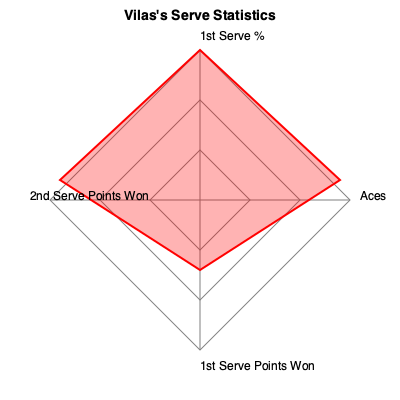Based on the radar chart showing Guillermo Vilas's serve statistics, which aspect of his serve appears to be his strongest? To determine Guillermo Vilas's strongest serving aspect, we need to analyze the radar chart:

1. The chart shows four serve statistics: Aces, 1st Serve %, 2nd Serve Points Won, and 1st Serve Points Won.

2. The red area represents Vilas's performance in each category.

3. The larger the area extends towards a vertex, the better the performance in that category.

4. Comparing the four categories:
   - Aces: Extends about halfway to the outer polygon
   - 1st Serve %: Extends close to the outer polygon
   - 2nd Serve Points Won: Extends slightly less than halfway to the outer polygon
   - 1st Serve Points Won: Extends about two-thirds to the outer polygon

5. The 1st Serve % clearly extends the furthest towards its vertex, reaching almost to the outer polygon.

Therefore, based on this radar chart, Guillermo Vilas's strongest serving aspect appears to be his 1st Serve percentage.
Answer: 1st Serve percentage 